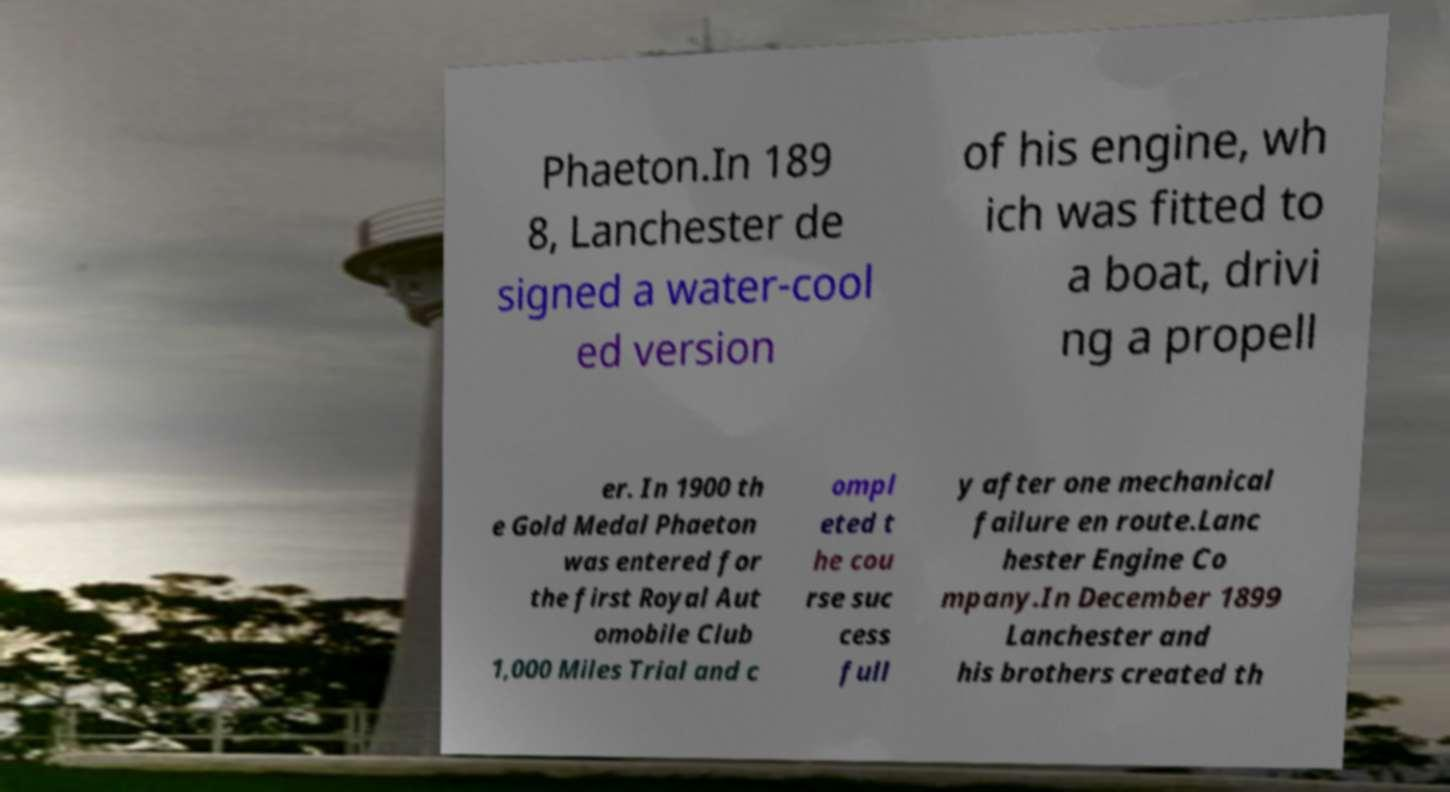Could you assist in decoding the text presented in this image and type it out clearly? Phaeton.In 189 8, Lanchester de signed a water-cool ed version of his engine, wh ich was fitted to a boat, drivi ng a propell er. In 1900 th e Gold Medal Phaeton was entered for the first Royal Aut omobile Club 1,000 Miles Trial and c ompl eted t he cou rse suc cess full y after one mechanical failure en route.Lanc hester Engine Co mpany.In December 1899 Lanchester and his brothers created th 